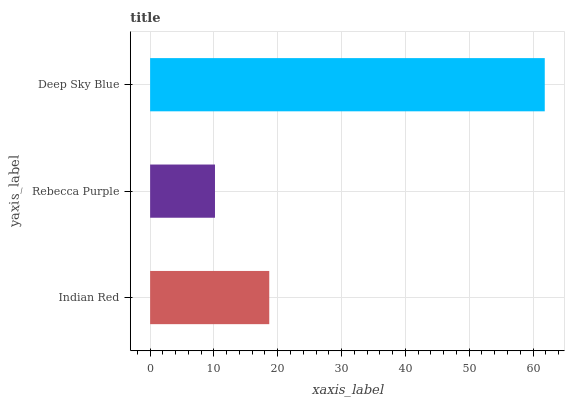Is Rebecca Purple the minimum?
Answer yes or no. Yes. Is Deep Sky Blue the maximum?
Answer yes or no. Yes. Is Deep Sky Blue the minimum?
Answer yes or no. No. Is Rebecca Purple the maximum?
Answer yes or no. No. Is Deep Sky Blue greater than Rebecca Purple?
Answer yes or no. Yes. Is Rebecca Purple less than Deep Sky Blue?
Answer yes or no. Yes. Is Rebecca Purple greater than Deep Sky Blue?
Answer yes or no. No. Is Deep Sky Blue less than Rebecca Purple?
Answer yes or no. No. Is Indian Red the high median?
Answer yes or no. Yes. Is Indian Red the low median?
Answer yes or no. Yes. Is Deep Sky Blue the high median?
Answer yes or no. No. Is Rebecca Purple the low median?
Answer yes or no. No. 